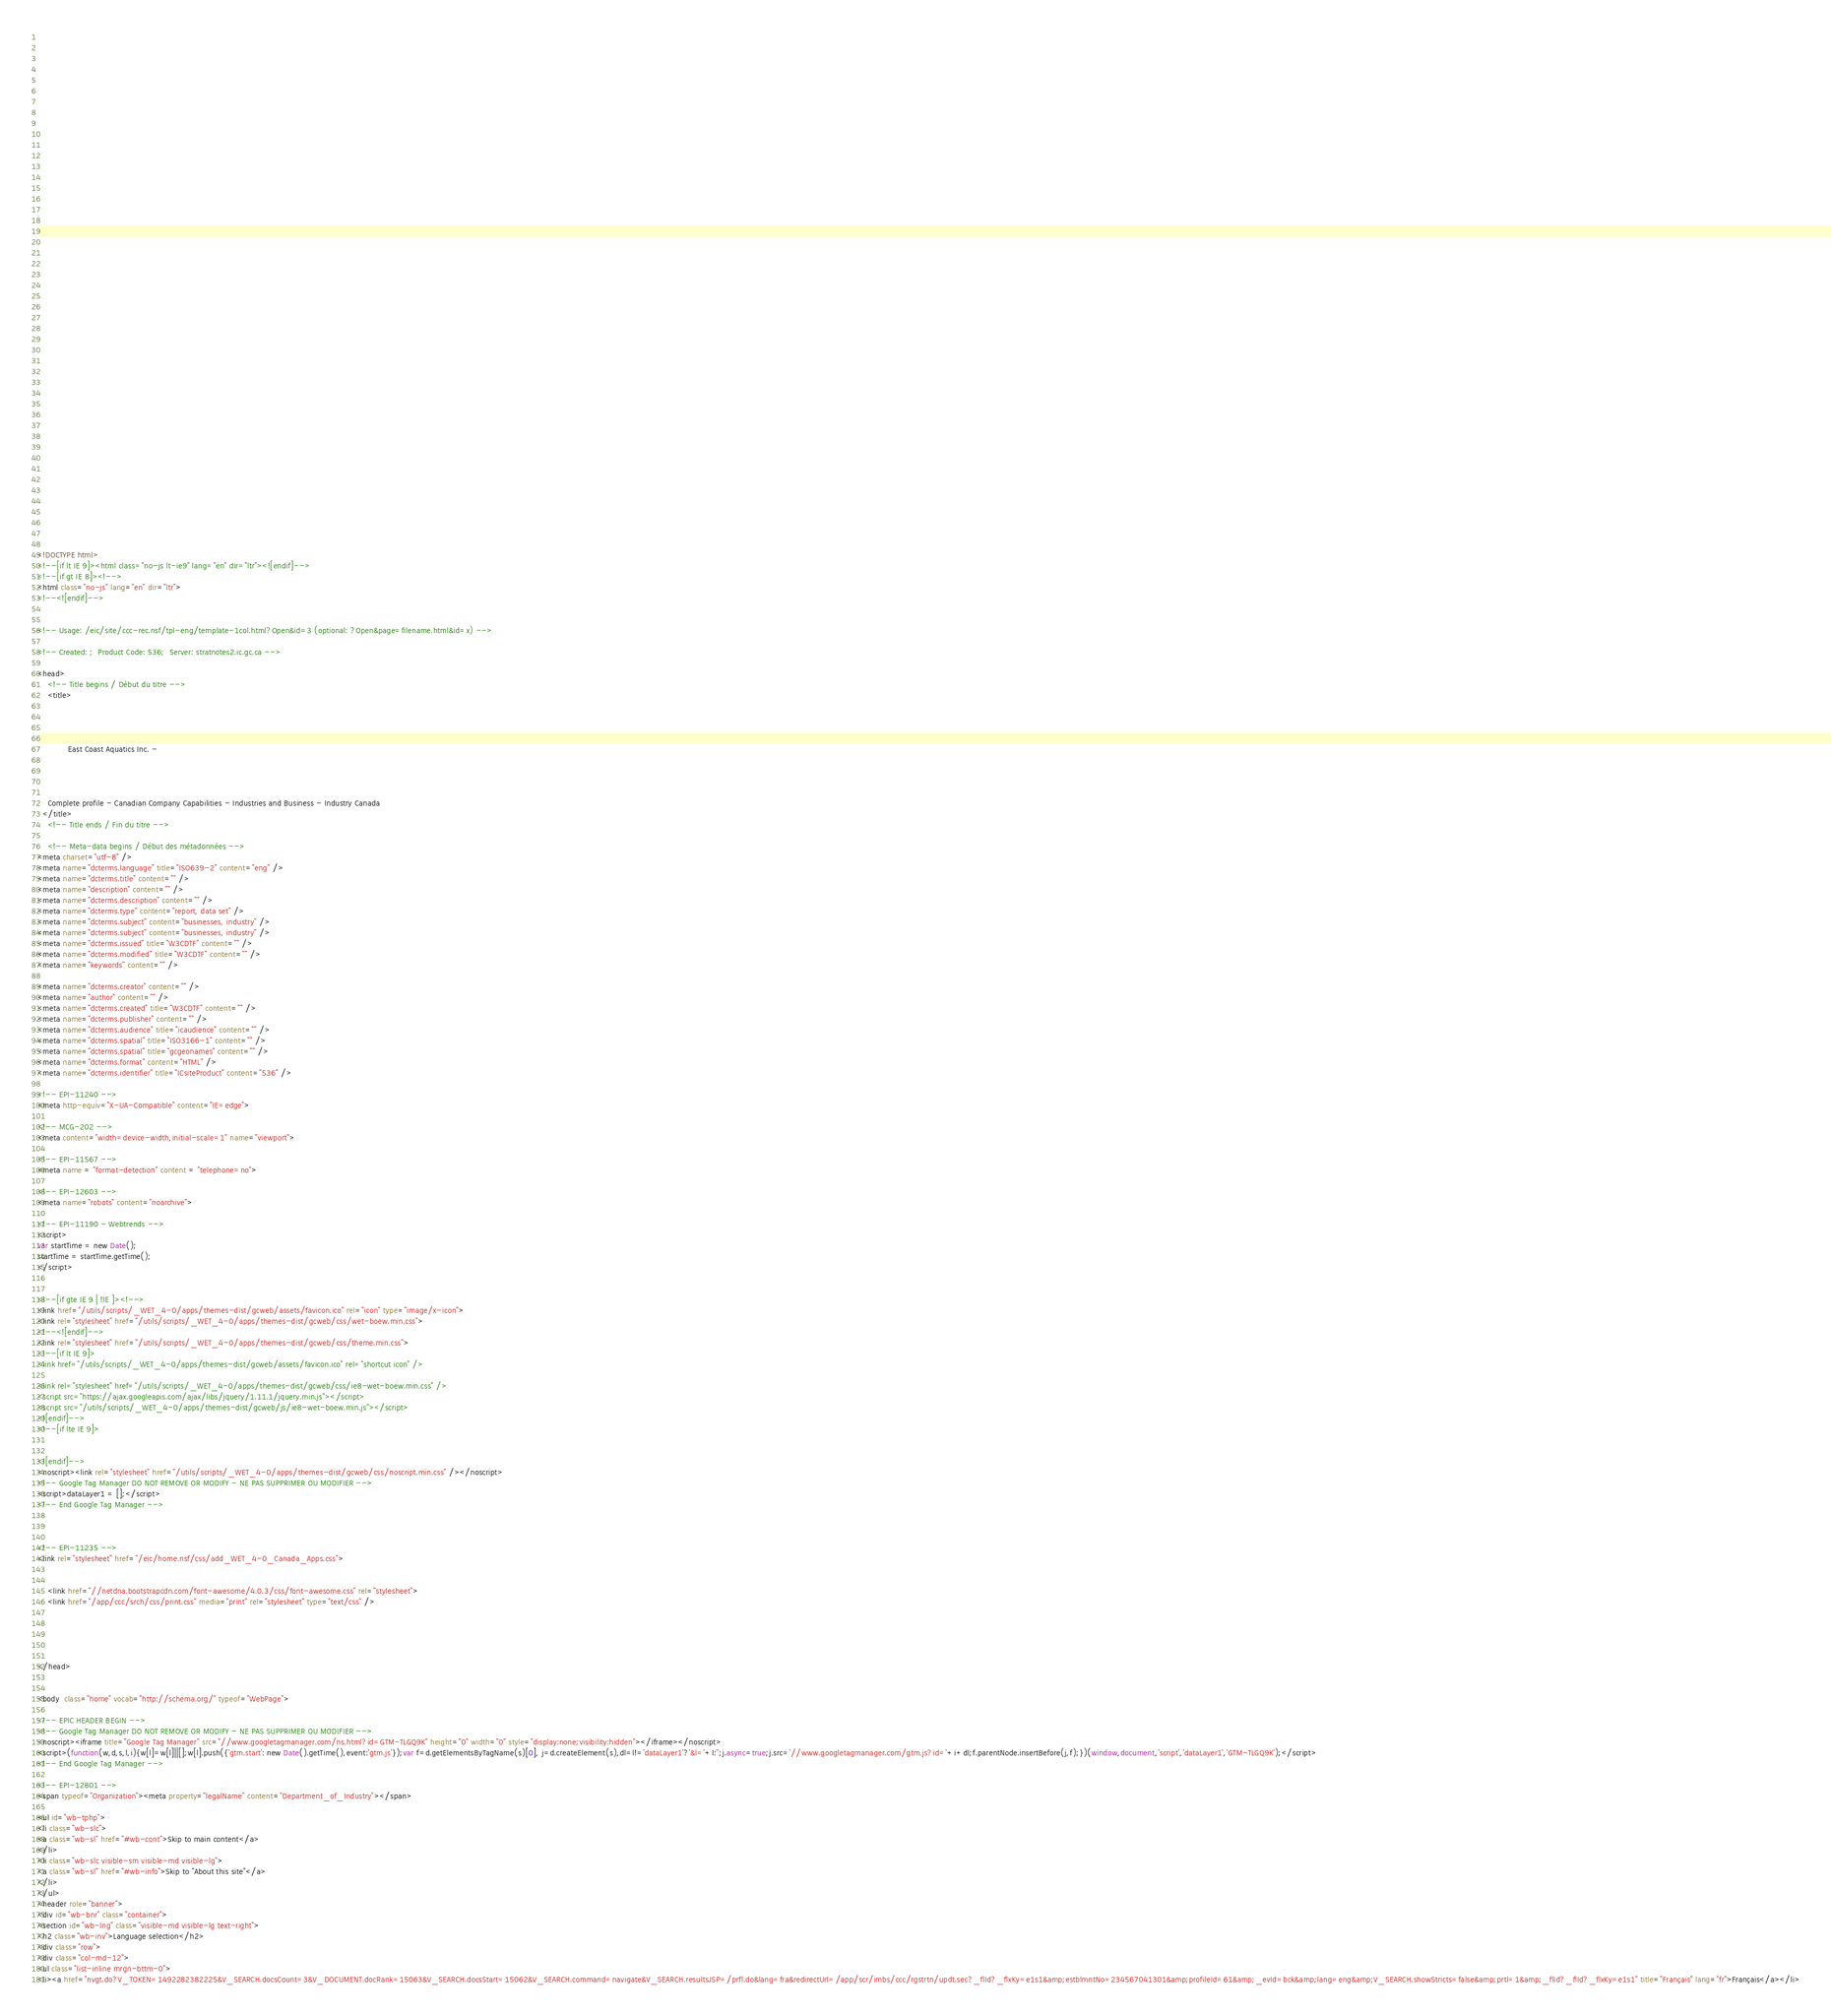Convert code to text. <code><loc_0><loc_0><loc_500><loc_500><_HTML_>


















	






  
  
  
  































	
	
	



<!DOCTYPE html>
<!--[if lt IE 9]><html class="no-js lt-ie9" lang="en" dir="ltr"><![endif]-->
<!--[if gt IE 8]><!-->
<html class="no-js" lang="en" dir="ltr">
<!--<![endif]-->


<!-- Usage: /eic/site/ccc-rec.nsf/tpl-eng/template-1col.html?Open&id=3 (optional: ?Open&page=filename.html&id=x) -->

<!-- Created: ;  Product Code: 536;  Server: stratnotes2.ic.gc.ca -->

<head>
	<!-- Title begins / Début du titre -->
	<title>
    
            
        
          
            East Coast Aquatics Inc. -
          
        
      
    
    Complete profile - Canadian Company Capabilities - Industries and Business - Industry Canada
  </title>
	<!-- Title ends / Fin du titre -->
 
	<!-- Meta-data begins / Début des métadonnées -->
<meta charset="utf-8" />
<meta name="dcterms.language" title="ISO639-2" content="eng" />
<meta name="dcterms.title" content="" />
<meta name="description" content="" />
<meta name="dcterms.description" content="" />
<meta name="dcterms.type" content="report, data set" />
<meta name="dcterms.subject" content="businesses, industry" />
<meta name="dcterms.subject" content="businesses, industry" />
<meta name="dcterms.issued" title="W3CDTF" content="" />
<meta name="dcterms.modified" title="W3CDTF" content="" />
<meta name="keywords" content="" />

<meta name="dcterms.creator" content="" />
<meta name="author" content="" />
<meta name="dcterms.created" title="W3CDTF" content="" />
<meta name="dcterms.publisher" content="" />
<meta name="dcterms.audience" title="icaudience" content="" />
<meta name="dcterms.spatial" title="ISO3166-1" content="" />
<meta name="dcterms.spatial" title="gcgeonames" content="" />
<meta name="dcterms.format" content="HTML" />
<meta name="dcterms.identifier" title="ICsiteProduct" content="536" />

<!-- EPI-11240 -->
<meta http-equiv="X-UA-Compatible" content="IE=edge">

<!-- MCG-202 -->
<meta content="width=device-width,initial-scale=1" name="viewport">

<!-- EPI-11567 -->
<meta name = "format-detection" content = "telephone=no">

<!-- EPI-12603 -->
<meta name="robots" content="noarchive">

<!-- EPI-11190 - Webtrends -->
<script>
var startTime = new Date();
startTime = startTime.getTime();
</script>


<!--[if gte IE 9 | !IE ]><!-->
<link href="/utils/scripts/_WET_4-0/apps/themes-dist/gcweb/assets/favicon.ico" rel="icon" type="image/x-icon">
<link rel="stylesheet" href="/utils/scripts/_WET_4-0/apps/themes-dist/gcweb/css/wet-boew.min.css">
<!--<![endif]-->
<link rel="stylesheet" href="/utils/scripts/_WET_4-0/apps/themes-dist/gcweb/css/theme.min.css">
<!--[if lt IE 9]>
<link href="/utils/scripts/_WET_4-0/apps/themes-dist/gcweb/assets/favicon.ico" rel="shortcut icon" />

<link rel="stylesheet" href="/utils/scripts/_WET_4-0/apps/themes-dist/gcweb/css/ie8-wet-boew.min.css" />
<script src="https://ajax.googleapis.com/ajax/libs/jquery/1.11.1/jquery.min.js"></script>
<script src="/utils/scripts/_WET_4-0/apps/themes-dist/gcweb/js/ie8-wet-boew.min.js"></script>
<![endif]-->
<!--[if lte IE 9]>


<![endif]-->
<noscript><link rel="stylesheet" href="/utils/scripts/_WET_4-0/apps/themes-dist/gcweb/css/noscript.min.css" /></noscript>
<!-- Google Tag Manager DO NOT REMOVE OR MODIFY - NE PAS SUPPRIMER OU MODIFIER -->
<script>dataLayer1 = [];</script>
<!-- End Google Tag Manager -->



<!-- EPI-11235 -->
<link rel="stylesheet" href="/eic/home.nsf/css/add_WET_4-0_Canada_Apps.css">


  	<link href="//netdna.bootstrapcdn.com/font-awesome/4.0.3/css/font-awesome.css" rel="stylesheet">
  	<link href="/app/ccc/srch/css/print.css" media="print" rel="stylesheet" type="text/css" />
   




</head>
 

<body  class="home" vocab="http://schema.org/" typeof="WebPage">
 
<!-- EPIC HEADER BEGIN -->
<!-- Google Tag Manager DO NOT REMOVE OR MODIFY - NE PAS SUPPRIMER OU MODIFIER -->
<noscript><iframe title="Google Tag Manager" src="//www.googletagmanager.com/ns.html?id=GTM-TLGQ9K" height="0" width="0" style="display:none;visibility:hidden"></iframe></noscript>
<script>(function(w,d,s,l,i){w[l]=w[l]||[];w[l].push({'gtm.start': new Date().getTime(),event:'gtm.js'});var f=d.getElementsByTagName(s)[0], j=d.createElement(s),dl=l!='dataLayer1'?'&l='+l:'';j.async=true;j.src='//www.googletagmanager.com/gtm.js?id='+i+dl;f.parentNode.insertBefore(j,f);})(window,document,'script','dataLayer1','GTM-TLGQ9K');</script>
<!-- End Google Tag Manager -->

<!-- EPI-12801 -->
<span typeof="Organization"><meta property="legalName" content="Department_of_Industry"></span>

<ul id="wb-tphp">
<li class="wb-slc">
<a class="wb-sl" href="#wb-cont">Skip to main content</a>
</li>
<li class="wb-slc visible-sm visible-md visible-lg">
<a class="wb-sl" href="#wb-info">Skip to "About this site"</a>
</li>
</ul>
<header role="banner">
<div id="wb-bnr" class="container">
<section id="wb-lng" class="visible-md visible-lg text-right">
<h2 class="wb-inv">Language selection</h2>
<div class="row">
<div class="col-md-12">
<ul class="list-inline mrgn-bttm-0">
<li><a href="nvgt.do?V_TOKEN=1492282382225&V_SEARCH.docsCount=3&V_DOCUMENT.docRank=15063&V_SEARCH.docsStart=15062&V_SEARCH.command=navigate&V_SEARCH.resultsJSP=/prfl.do&lang=fra&redirectUrl=/app/scr/imbs/ccc/rgstrtn/updt.sec?_flId?_flxKy=e1s1&amp;estblmntNo=234567041301&amp;profileId=61&amp;_evId=bck&amp;lang=eng&amp;V_SEARCH.showStricts=false&amp;prtl=1&amp;_flId?_flId?_flxKy=e1s1" title="Français" lang="fr">Français</a></li></code> 